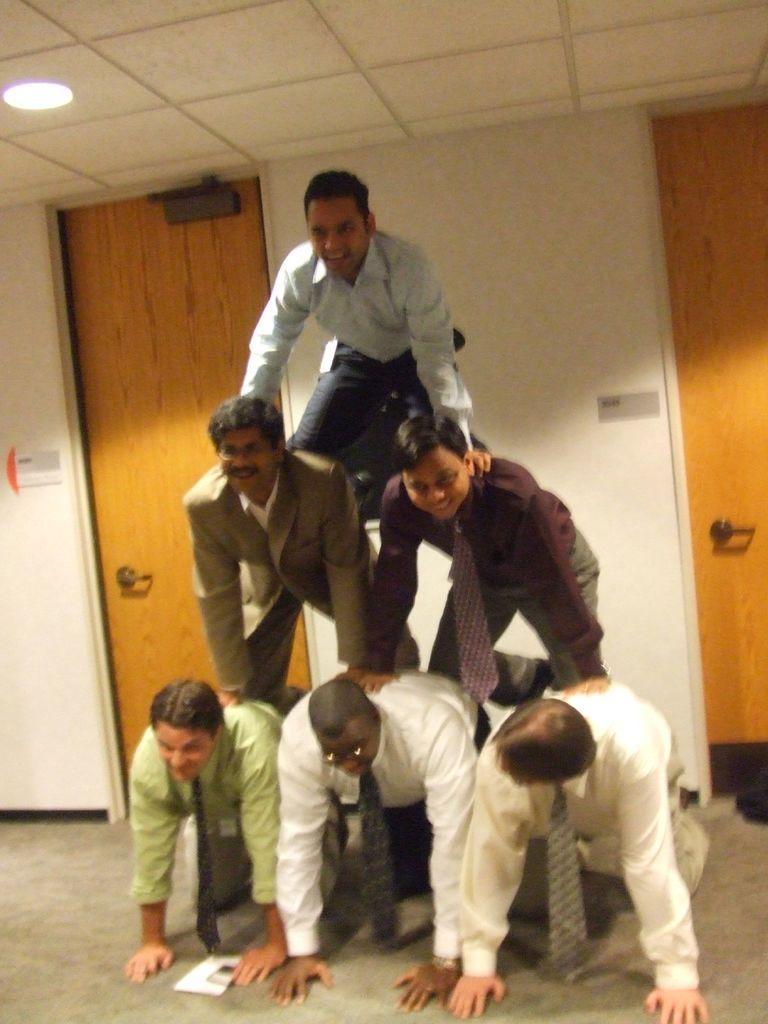In one or two sentences, can you explain what this image depicts? In this image I can see the human pyramid. In the background there are two doors to the wall. On the left side there is a light attached to the roof. 